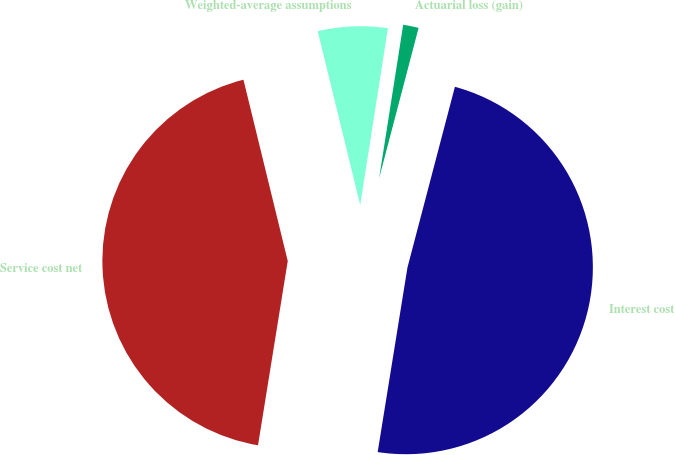Convert chart. <chart><loc_0><loc_0><loc_500><loc_500><pie_chart><fcel>Service cost net<fcel>Interest cost<fcel>Actuarial loss (gain)<fcel>Weighted-average assumptions<nl><fcel>43.64%<fcel>48.46%<fcel>1.61%<fcel>6.29%<nl></chart> 